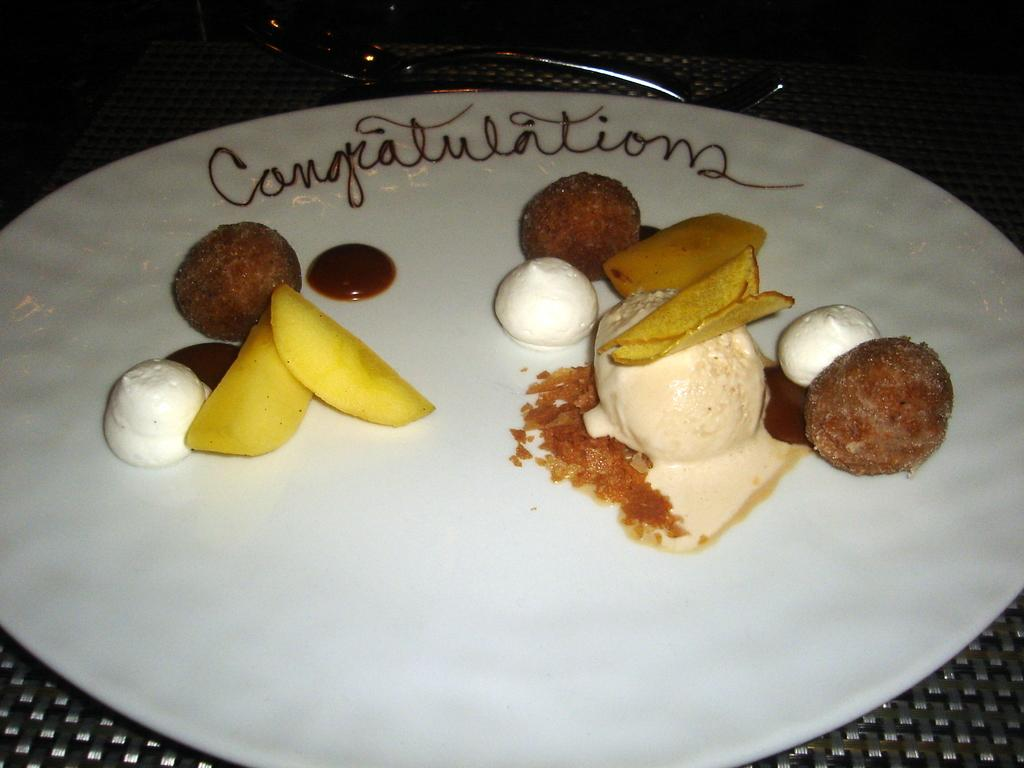What is on the plate that is visible in the image? The plate contains a scoop of ice cream and other food items. Where is the plate located in the image? The plate is placed on a table. What utensil might be used to eat the ice cream in the image? There is a spoon visible in the background that could be used to eat the ice cream. How many centimeters of paper are visible in the image? There is no paper present in the image, so it is not possible to determine the number of centimeters of paper visible. 